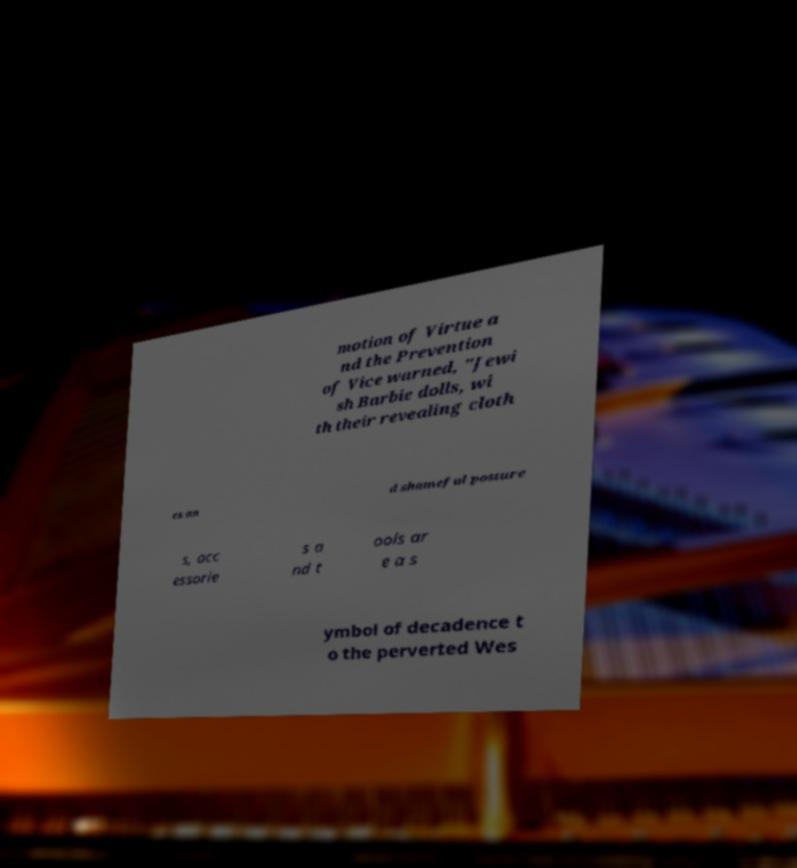Please read and relay the text visible in this image. What does it say? motion of Virtue a nd the Prevention of Vice warned, "Jewi sh Barbie dolls, wi th their revealing cloth es an d shameful posture s, acc essorie s a nd t ools ar e a s ymbol of decadence t o the perverted Wes 